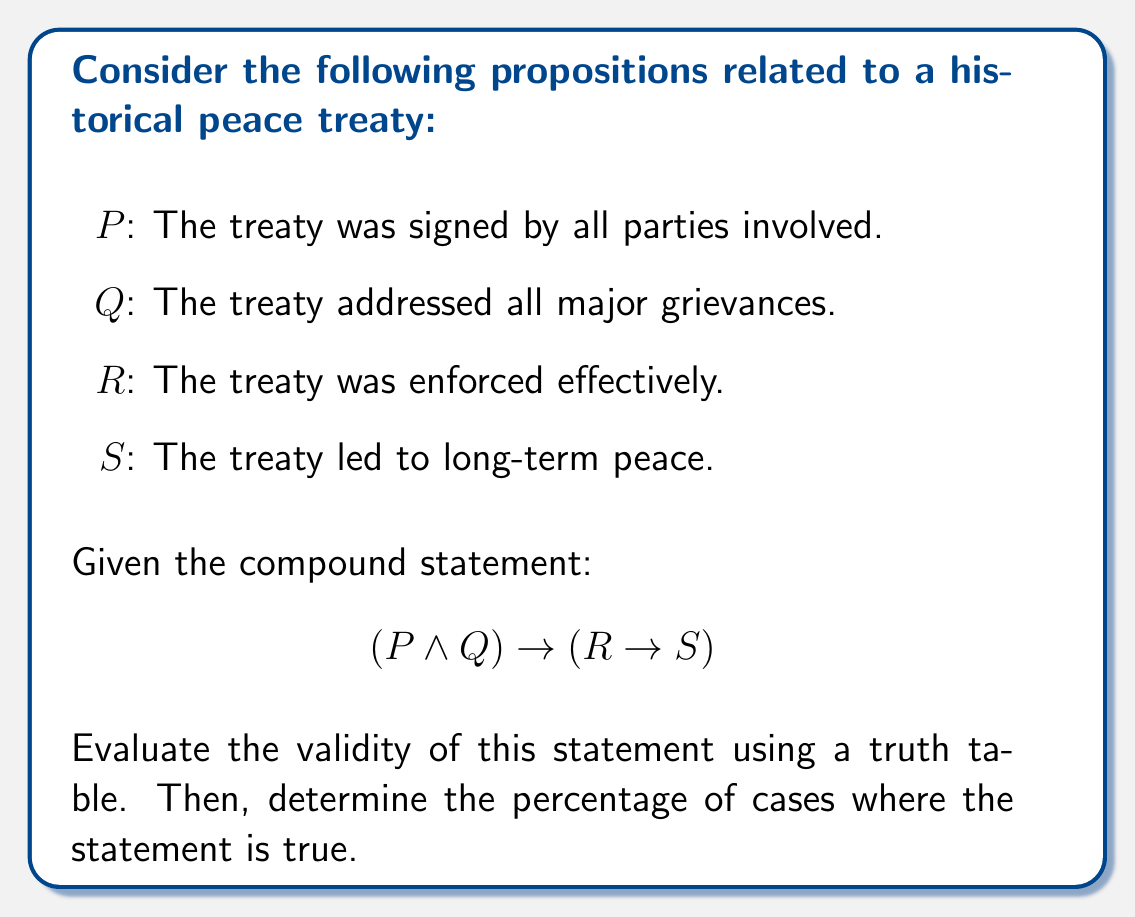Provide a solution to this math problem. To evaluate the validity of the statement $(P \land Q) \rightarrow (R \rightarrow S)$, we need to construct a truth table and analyze the results.

Step 1: Identify the atomic propositions: P, Q, R, and S.

Step 2: Create a truth table with 16 rows (2^4 = 16 possible combinations).

Step 3: Evaluate the compound statement:
- First, calculate $P \land Q$
- Then, calculate $R \rightarrow S$
- Finally, calculate $(P \land Q) \rightarrow (R \rightarrow S)$

Truth Table:

| P | Q | R | S | P ∧ Q | R → S | (P ∧ Q) → (R → S) |
|---|---|---|---|-------|-------|-------------------|
| T | T | T | T |   T   |   T   |         T         |
| T | T | T | F |   T   |   F   |         F         |
| T | T | F | T |   T   |   T   |         T         |
| T | T | F | F |   T   |   T   |         T         |
| T | F | T | T |   F   |   T   |         T         |
| T | F | T | F |   F   |   F   |         T         |
| T | F | F | T |   F   |   T   |         T         |
| T | F | F | F |   F   |   T   |         T         |
| F | T | T | T |   F   |   T   |         T         |
| F | T | T | F |   F   |   F   |         T         |
| F | T | F | T |   F   |   T   |         T         |
| F | T | F | F |   F   |   T   |         T         |
| F | F | T | T |   F   |   T   |         T         |
| F | F | T | F |   F   |   F   |         T         |
| F | F | F | T |   F   |   T   |         T         |
| F | F | F | F |   F   |   T   |         T         |

Step 4: Count the number of true outcomes in the final column.
There are 15 true outcomes out of 16 total outcomes.

Step 5: Calculate the percentage of true outcomes.
Percentage = (Number of true outcomes / Total outcomes) × 100
Percentage = (15 / 16) × 100 = 93.75%

This high percentage suggests that the statement is generally valid, but not always true. The only case where it's false is when P and Q are true, R is true, and S is false, which represents a situation where all conditions for a successful treaty are met, but long-term peace is not achieved.
Answer: 93.75% true 